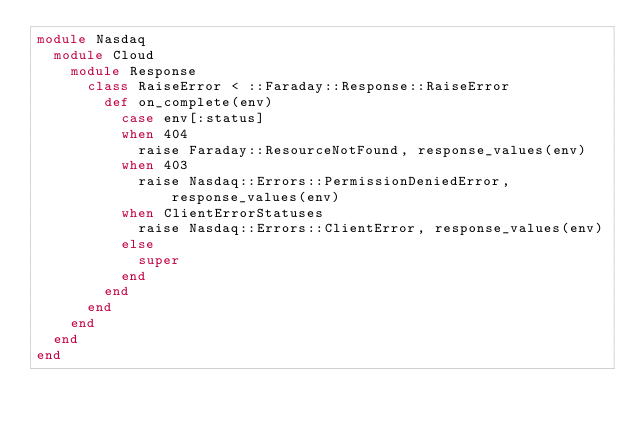<code> <loc_0><loc_0><loc_500><loc_500><_Ruby_>module Nasdaq
  module Cloud
    module Response
      class RaiseError < ::Faraday::Response::RaiseError
        def on_complete(env)
          case env[:status]
          when 404
            raise Faraday::ResourceNotFound, response_values(env)
          when 403
            raise Nasdaq::Errors::PermissionDeniedError, response_values(env)
          when ClientErrorStatuses
            raise Nasdaq::Errors::ClientError, response_values(env)
          else
            super
          end
        end
      end
    end
  end
end
</code> 